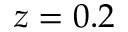Convert formula to latex. <formula><loc_0><loc_0><loc_500><loc_500>z = 0 . 2</formula> 